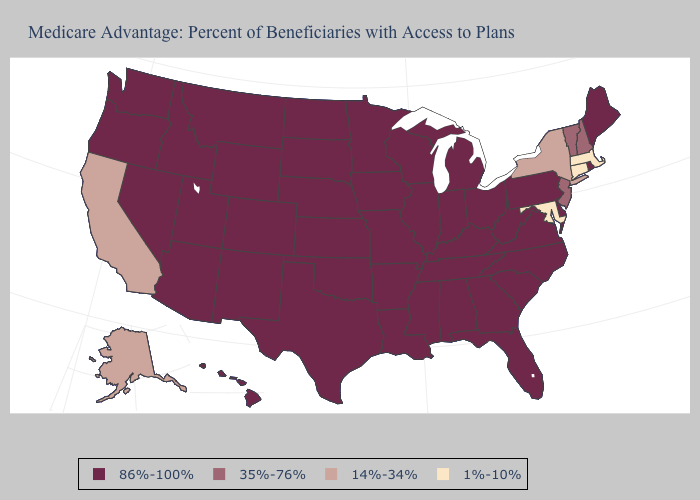Does the map have missing data?
Answer briefly. No. Name the states that have a value in the range 14%-34%?
Short answer required. Alaska, California, New York. Among the states that border New Jersey , which have the highest value?
Give a very brief answer. Delaware, Pennsylvania. Which states hav the highest value in the South?
Be succinct. Alabama, Arkansas, Delaware, Florida, Georgia, Kentucky, Louisiana, Mississippi, North Carolina, Oklahoma, South Carolina, Tennessee, Texas, Virginia, West Virginia. What is the highest value in the Northeast ?
Answer briefly. 86%-100%. Does California have the lowest value in the West?
Write a very short answer. Yes. Does Maryland have the highest value in the South?
Give a very brief answer. No. Name the states that have a value in the range 35%-76%?
Quick response, please. New Hampshire, New Jersey, Vermont. Among the states that border New Jersey , does Delaware have the lowest value?
Write a very short answer. No. What is the highest value in the USA?
Write a very short answer. 86%-100%. What is the highest value in states that border California?
Short answer required. 86%-100%. What is the lowest value in the Northeast?
Answer briefly. 1%-10%. What is the value of Tennessee?
Short answer required. 86%-100%. What is the highest value in the USA?
Quick response, please. 86%-100%. 